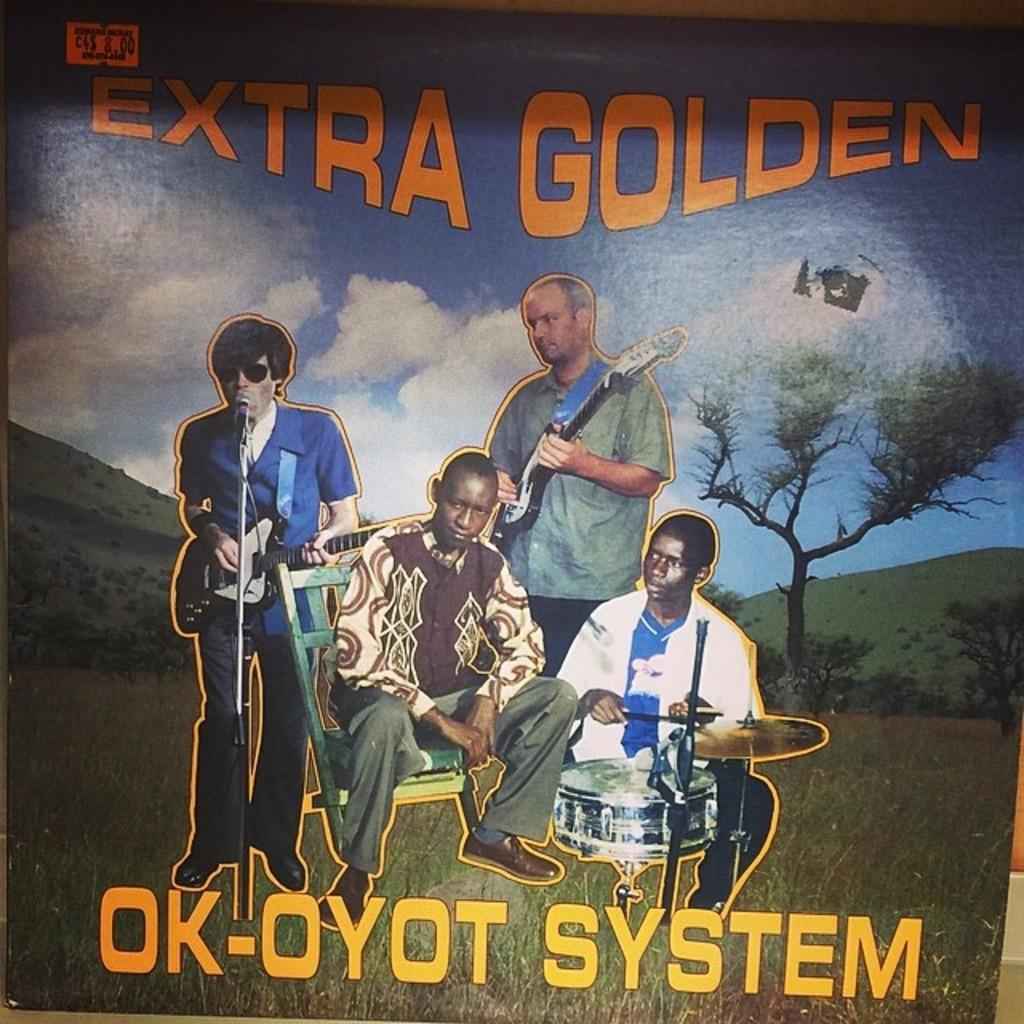<image>
Share a concise interpretation of the image provided. some artwork that has the words extra golden at the top 